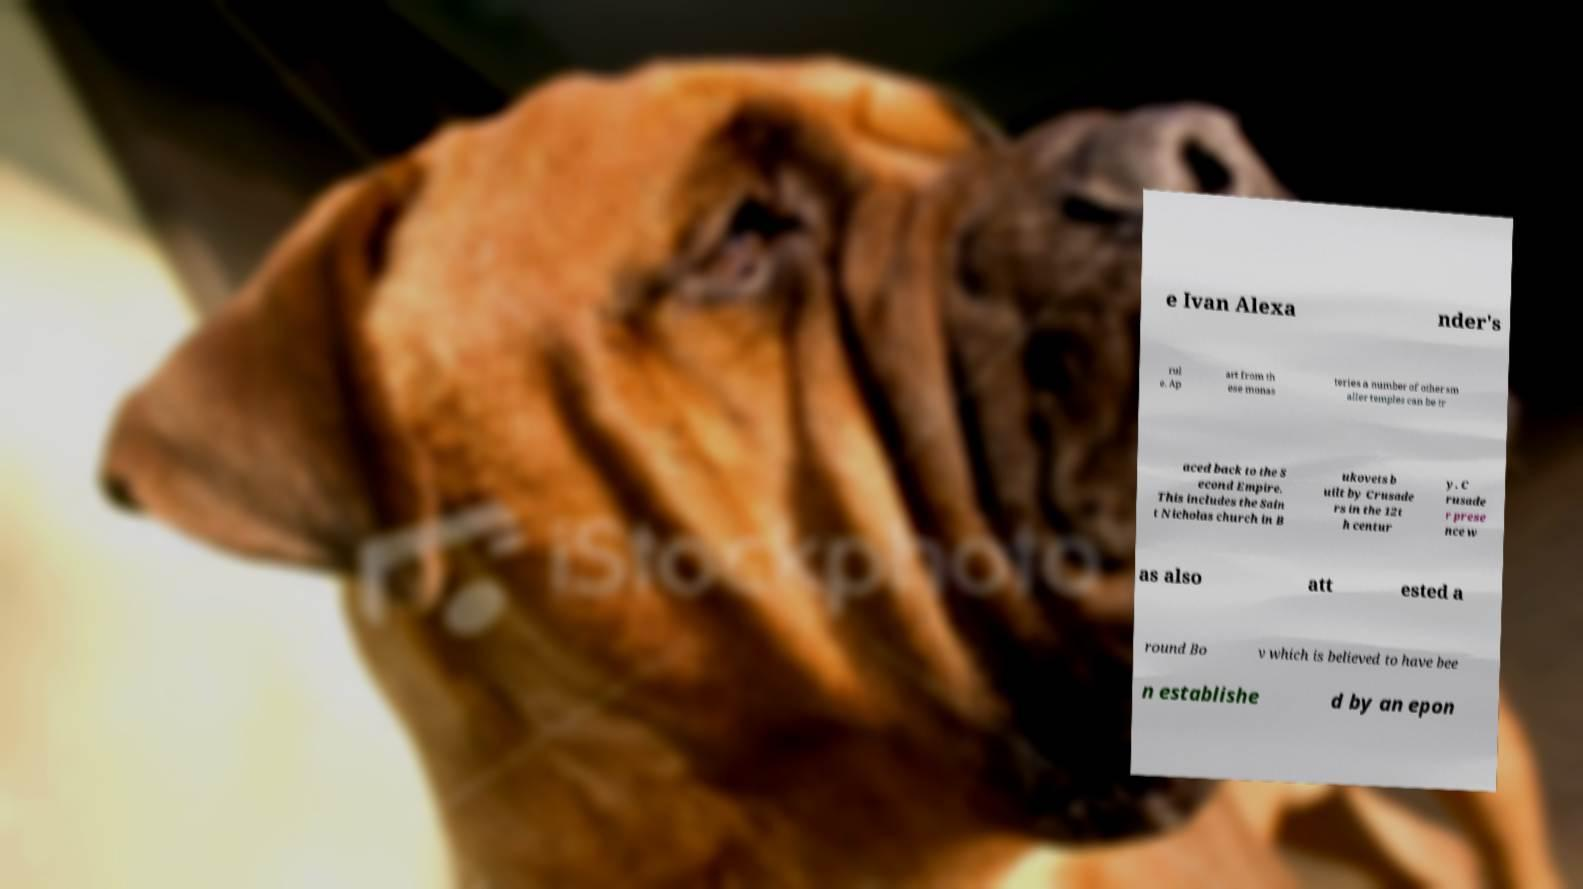Please identify and transcribe the text found in this image. e Ivan Alexa nder's rul e. Ap art from th ese monas teries a number of other sm aller temples can be tr aced back to the S econd Empire. This includes the Sain t Nicholas church in B ukovets b uilt by Crusade rs in the 12t h centur y. C rusade r prese nce w as also att ested a round Bo v which is believed to have bee n establishe d by an epon 